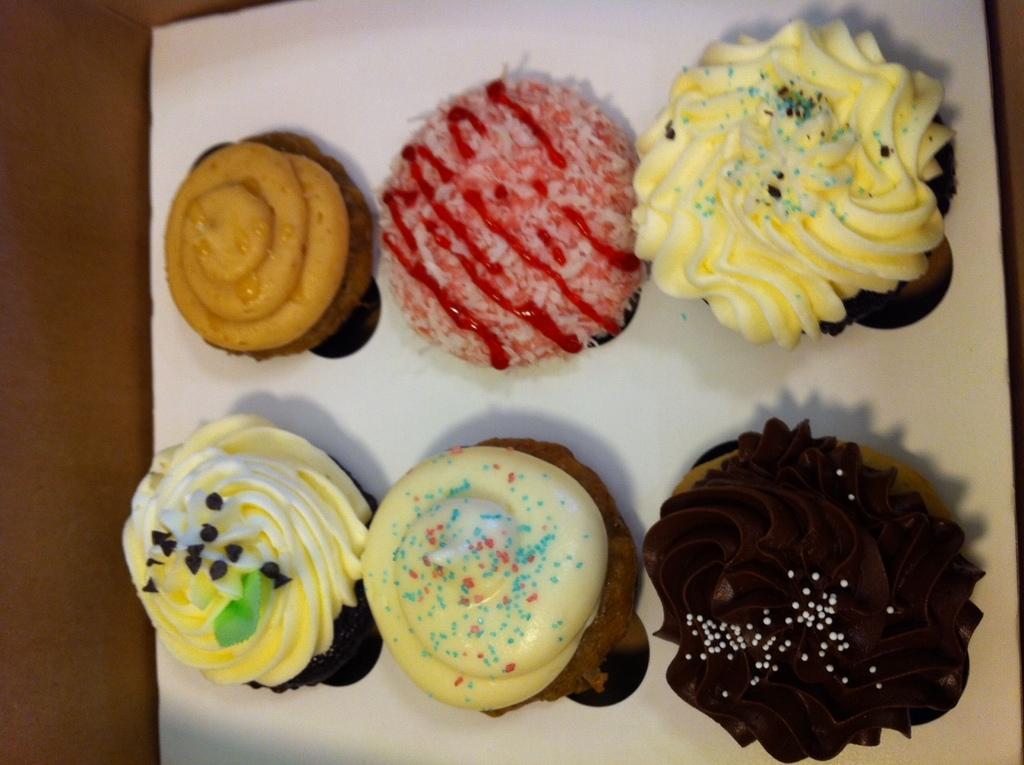Please provide a concise description of this image. This picture contains cupcakes which are placed on the white tray. On the left corner of the picture, it is brown in color and it is blurred. 